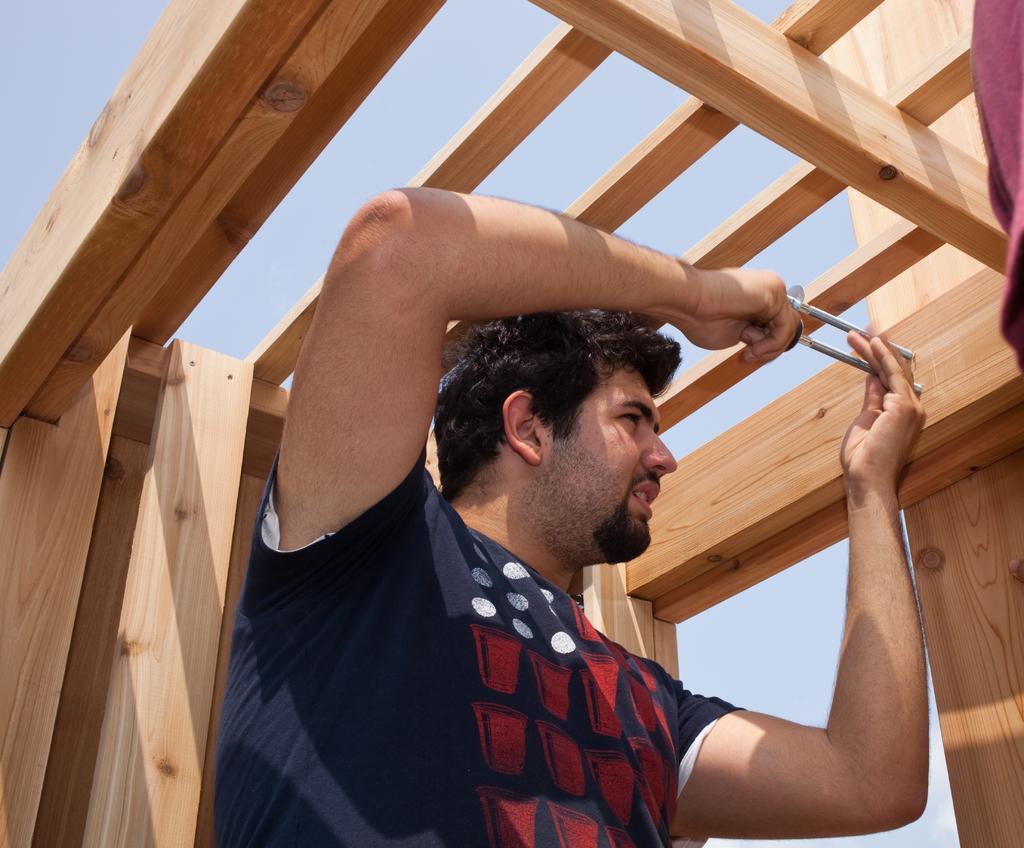Can you describe this image briefly? In this image there is a person holding a tool in his hand is fixing a screw on a wooden stick. 